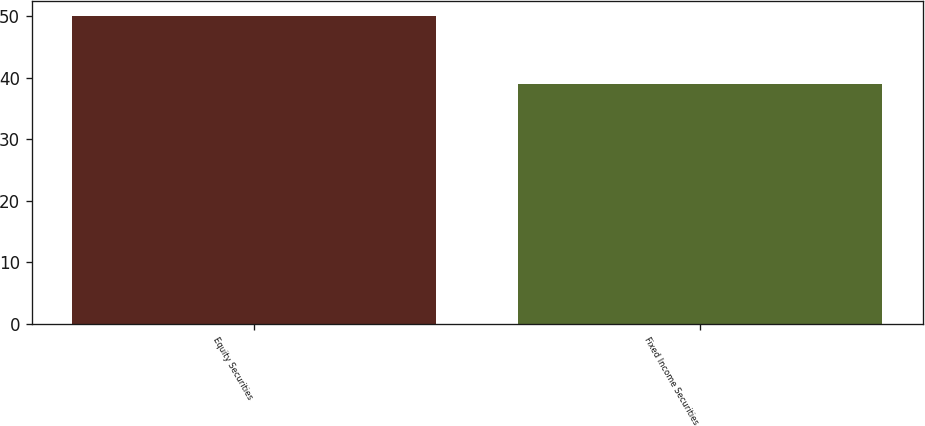<chart> <loc_0><loc_0><loc_500><loc_500><bar_chart><fcel>Equity Securities<fcel>Fixed Income Securities<nl><fcel>50<fcel>39<nl></chart> 